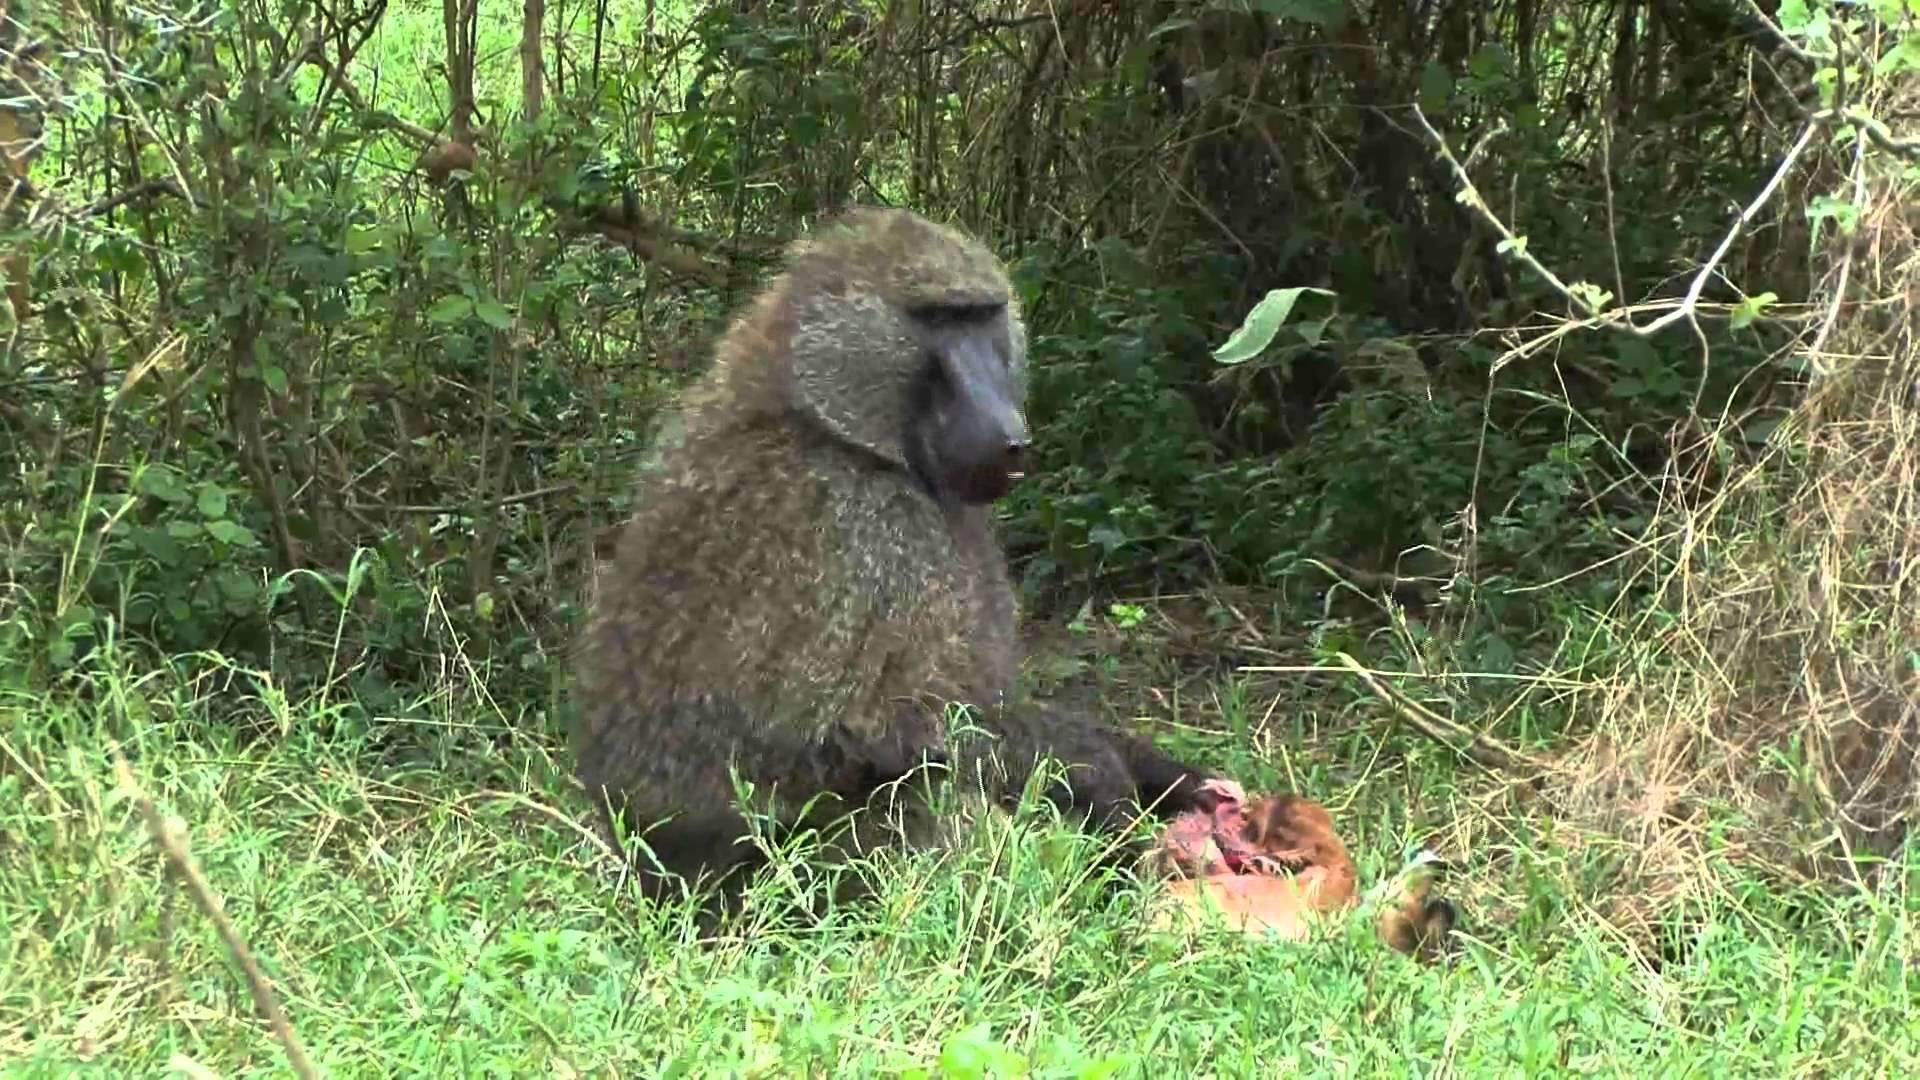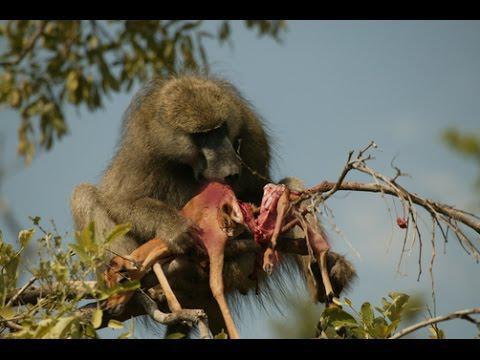The first image is the image on the left, the second image is the image on the right. Considering the images on both sides, is "A deceased animal is on the grass in front of a primate." valid? Answer yes or no. Yes. The first image is the image on the left, the second image is the image on the right. For the images shown, is this caption "An adult baboon is touching a dark-haired young baboon in one image." true? Answer yes or no. No. 